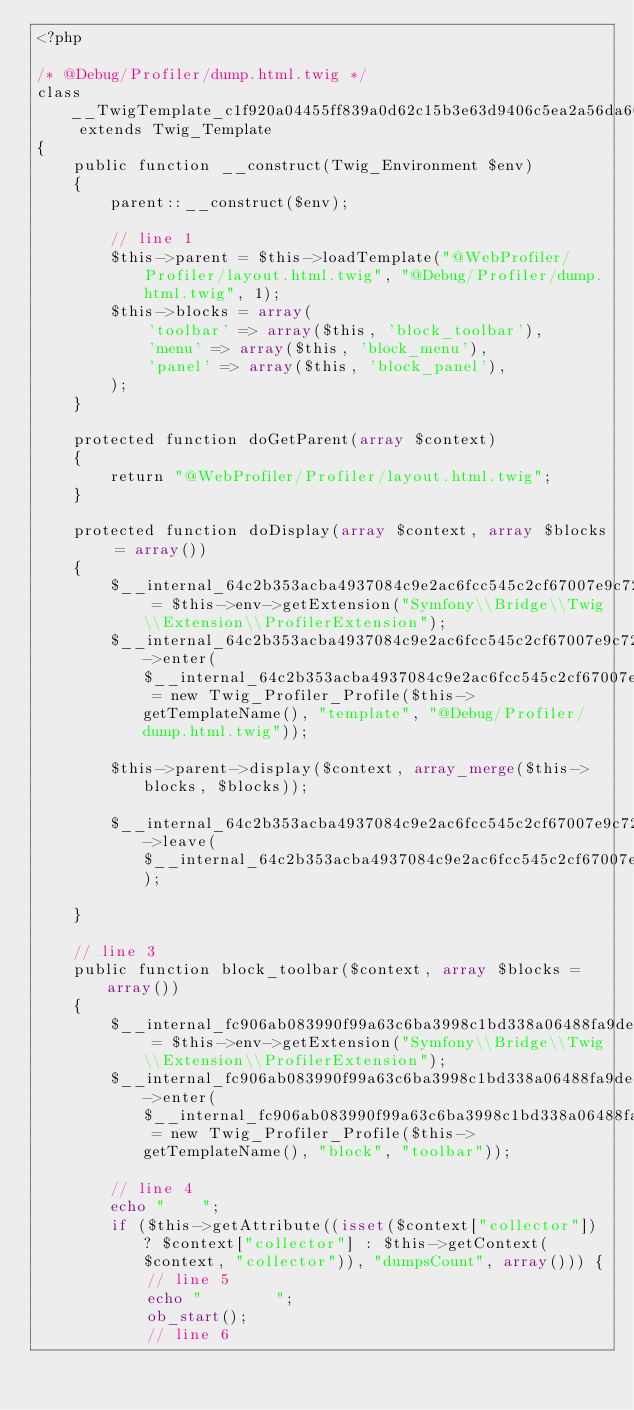<code> <loc_0><loc_0><loc_500><loc_500><_PHP_><?php

/* @Debug/Profiler/dump.html.twig */
class __TwigTemplate_c1f920a04455ff839a0d62c15b3e63d9406c5ea2a56da60da92365a863eb3983 extends Twig_Template
{
    public function __construct(Twig_Environment $env)
    {
        parent::__construct($env);

        // line 1
        $this->parent = $this->loadTemplate("@WebProfiler/Profiler/layout.html.twig", "@Debug/Profiler/dump.html.twig", 1);
        $this->blocks = array(
            'toolbar' => array($this, 'block_toolbar'),
            'menu' => array($this, 'block_menu'),
            'panel' => array($this, 'block_panel'),
        );
    }

    protected function doGetParent(array $context)
    {
        return "@WebProfiler/Profiler/layout.html.twig";
    }

    protected function doDisplay(array $context, array $blocks = array())
    {
        $__internal_64c2b353acba4937084c9e2ac6fcc545c2cf67007e9c7227ea38abd8671c2adb = $this->env->getExtension("Symfony\\Bridge\\Twig\\Extension\\ProfilerExtension");
        $__internal_64c2b353acba4937084c9e2ac6fcc545c2cf67007e9c7227ea38abd8671c2adb->enter($__internal_64c2b353acba4937084c9e2ac6fcc545c2cf67007e9c7227ea38abd8671c2adb_prof = new Twig_Profiler_Profile($this->getTemplateName(), "template", "@Debug/Profiler/dump.html.twig"));

        $this->parent->display($context, array_merge($this->blocks, $blocks));
        
        $__internal_64c2b353acba4937084c9e2ac6fcc545c2cf67007e9c7227ea38abd8671c2adb->leave($__internal_64c2b353acba4937084c9e2ac6fcc545c2cf67007e9c7227ea38abd8671c2adb_prof);

    }

    // line 3
    public function block_toolbar($context, array $blocks = array())
    {
        $__internal_fc906ab083990f99a63c6ba3998c1bd338a06488fa9decb01a30602f31b288dd = $this->env->getExtension("Symfony\\Bridge\\Twig\\Extension\\ProfilerExtension");
        $__internal_fc906ab083990f99a63c6ba3998c1bd338a06488fa9decb01a30602f31b288dd->enter($__internal_fc906ab083990f99a63c6ba3998c1bd338a06488fa9decb01a30602f31b288dd_prof = new Twig_Profiler_Profile($this->getTemplateName(), "block", "toolbar"));

        // line 4
        echo "    ";
        if ($this->getAttribute((isset($context["collector"]) ? $context["collector"] : $this->getContext($context, "collector")), "dumpsCount", array())) {
            // line 5
            echo "        ";
            ob_start();
            // line 6</code> 